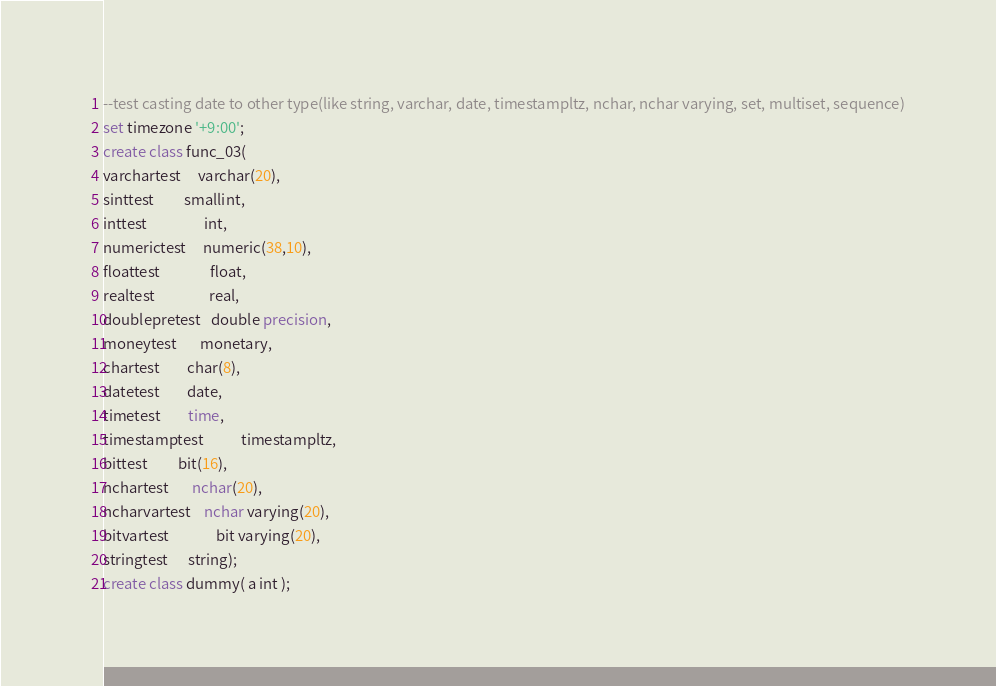<code> <loc_0><loc_0><loc_500><loc_500><_SQL_>--test casting date to other type(like string, varchar, date, timestampltz, nchar, nchar varying, set, multiset, sequence)
set timezone '+9:00';
create class func_03(
varchartest     varchar(20),
sinttest         smallint,
inttest                 int,
numerictest     numeric(38,10),
floattest               float,
realtest                real,
doublepretest   double precision,
moneytest       monetary,
chartest        char(8),
datetest        date,
timetest        time,
timestamptest           timestampltz,
bittest         bit(16),
nchartest       nchar(20),
ncharvartest    nchar varying(20),
bitvartest              bit varying(20),
stringtest      string);
create class dummy( a int );</code> 